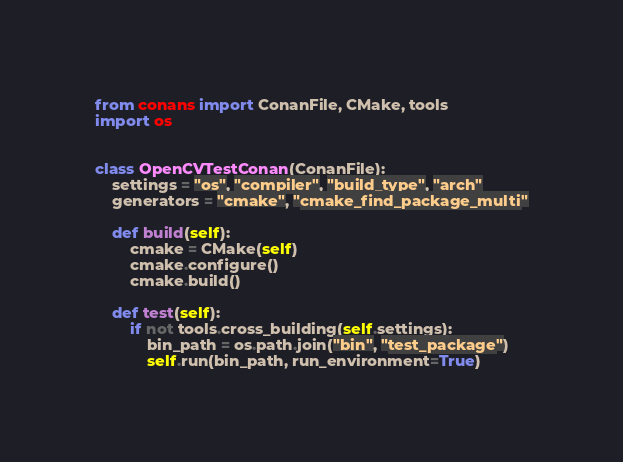Convert code to text. <code><loc_0><loc_0><loc_500><loc_500><_Python_>from conans import ConanFile, CMake, tools
import os


class OpenCVTestConan(ConanFile):
    settings = "os", "compiler", "build_type", "arch"
    generators = "cmake", "cmake_find_package_multi"

    def build(self):
        cmake = CMake(self)
        cmake.configure()
        cmake.build()

    def test(self):
        if not tools.cross_building(self.settings):
            bin_path = os.path.join("bin", "test_package")
            self.run(bin_path, run_environment=True)
</code> 